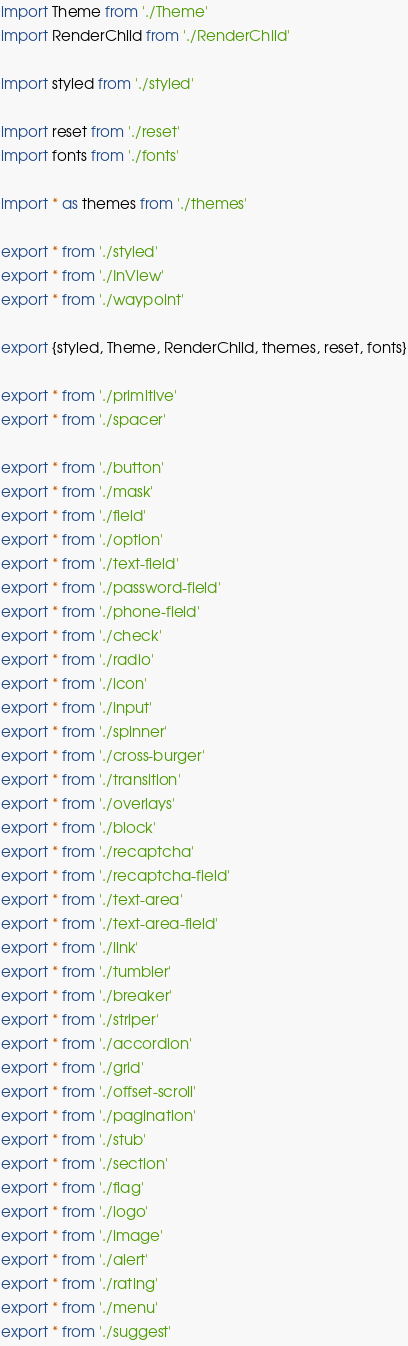Convert code to text. <code><loc_0><loc_0><loc_500><loc_500><_TypeScript_>import Theme from './Theme'
import RenderChild from './RenderChild'

import styled from './styled'

import reset from './reset'
import fonts from './fonts'

import * as themes from './themes'

export * from './styled'
export * from './InView'
export * from './waypoint'

export {styled, Theme, RenderChild, themes, reset, fonts}

export * from './primitive'
export * from './spacer'

export * from './button'
export * from './mask'
export * from './field'
export * from './option'
export * from './text-field'
export * from './password-field'
export * from './phone-field'
export * from './check'
export * from './radio'
export * from './icon'
export * from './input'
export * from './spinner'
export * from './cross-burger'
export * from './transition'
export * from './overlays'
export * from './block'
export * from './recaptcha'
export * from './recaptcha-field'
export * from './text-area'
export * from './text-area-field'
export * from './link'
export * from './tumbler'
export * from './breaker'
export * from './striper'
export * from './accordion'
export * from './grid'
export * from './offset-scroll'
export * from './pagination'
export * from './stub'
export * from './section'
export * from './flag'
export * from './logo'
export * from './image'
export * from './alert'
export * from './rating'
export * from './menu'
export * from './suggest'
</code> 